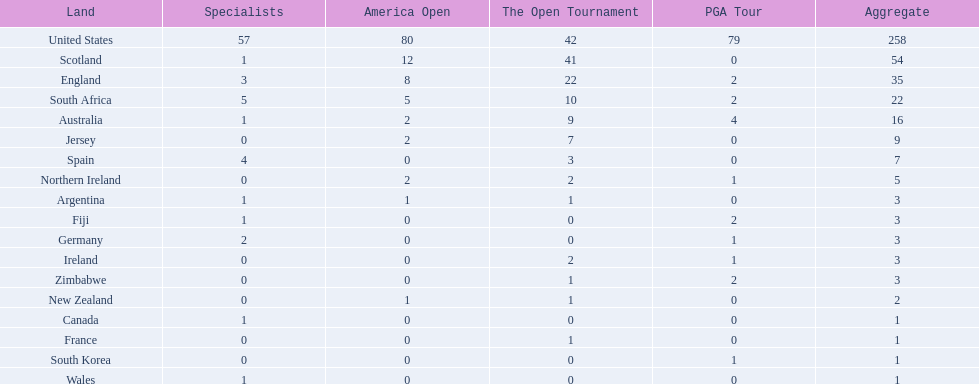Which country has the most pga championships. United States. 